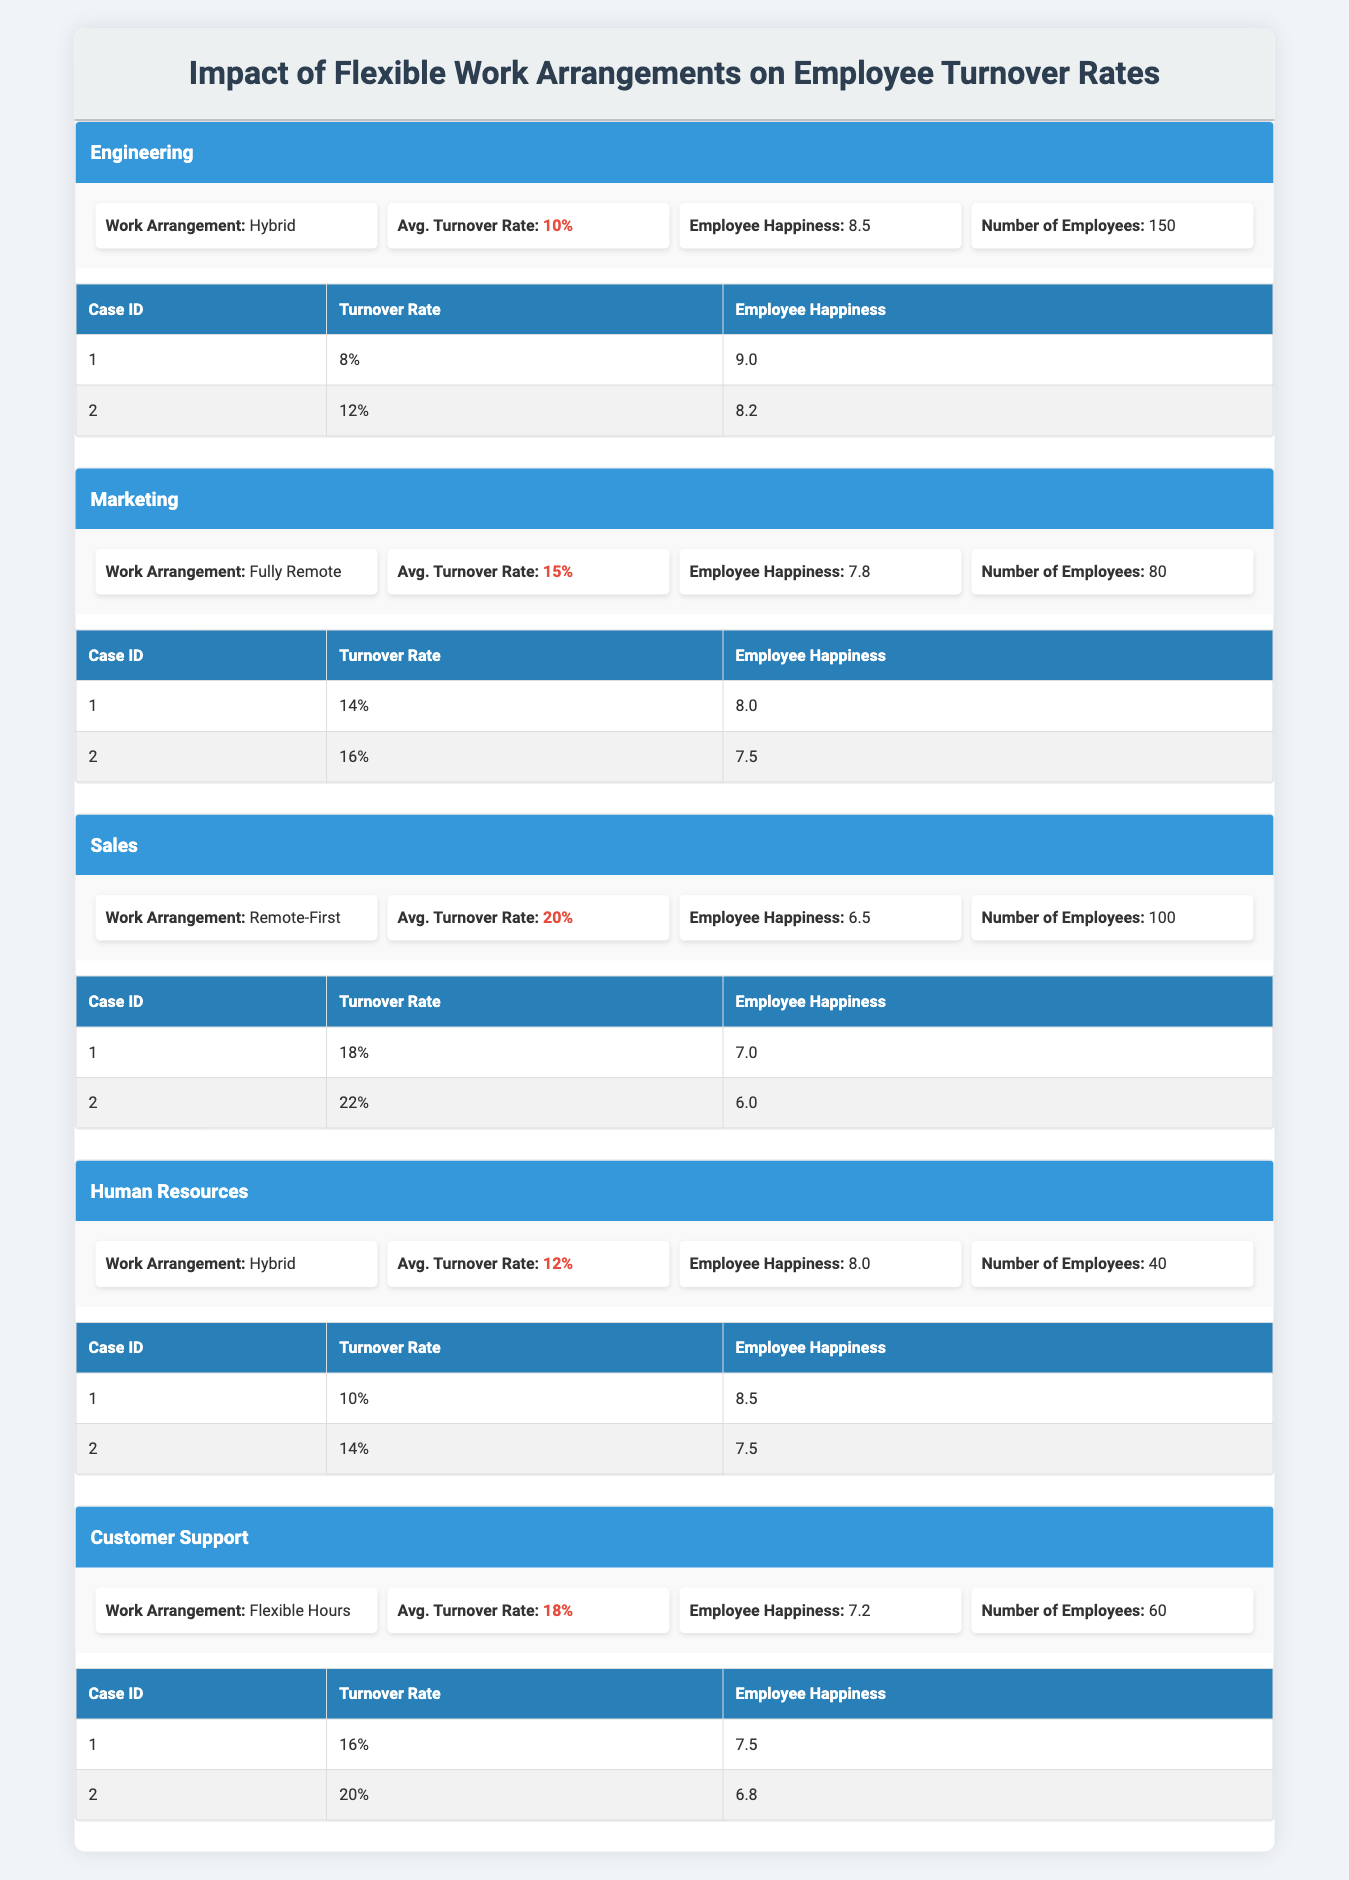What is the average turnover rate for the Engineering department? The Engineering department's average turnover rate is provided directly in the table, listed as 10%.
Answer: 10% What is the employee happiness score for the Sales department? The employee happiness score for the Sales department is clearly stated in the table as 6.5.
Answer: 6.5 Which department has the highest average turnover rate? By comparing the average turnover rates in the table, Sales has the highest at 20%.
Answer: Sales Is the employee happiness score for Marketing higher than that for Human Resources? The employee happiness score for Marketing is 7.8, while for Human Resources it is 8.0. Since 7.8 is less than 8.0, the statement is false.
Answer: No What is the difference in average turnover rate between the Customer Support and Marketing departments? The average turnover rate for Customer Support is 18%, and for Marketing, it is 15%. The difference is 18% - 15% = 3%.
Answer: 3% What is the average employee happiness score across all departments? The happiness scores can be summed: (8.5 + 7.8 + 6.5 + 8.0 + 7.2) = 38. Total departments = 5. Average = 38/5 = 7.6.
Answer: 7.6 Which department has the lowest employee happiness score? By reviewing the happiness scores, the Sales department has the lowest score at 6.5.
Answer: Sales If the turnover rate increases by 2% in the Human Resources department, what would be the new average turnover rate? The current average turnover rate for Human Resources is 12%. If it increases by 2%, the new rate would be 12% + 2% = 14%.
Answer: 14% Is it true that all departments with a hybrid work arrangement have an employee happiness score above 8? The Engineering department has a happiness score of 8.5, and Human Resources has 8.0, thus not all departments with a hybrid arrangement exceed 8, making the statement false.
Answer: No 